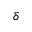Convert formula to latex. <formula><loc_0><loc_0><loc_500><loc_500>\delta</formula> 